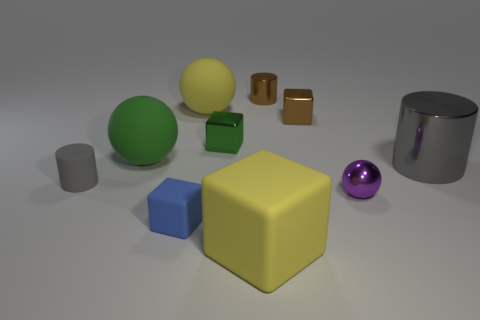Subtract all cylinders. How many objects are left? 7 Subtract 1 green cubes. How many objects are left? 9 Subtract all tiny brown shiny cylinders. Subtract all small yellow rubber blocks. How many objects are left? 9 Add 5 tiny purple things. How many tiny purple things are left? 6 Add 1 small gray things. How many small gray things exist? 2 